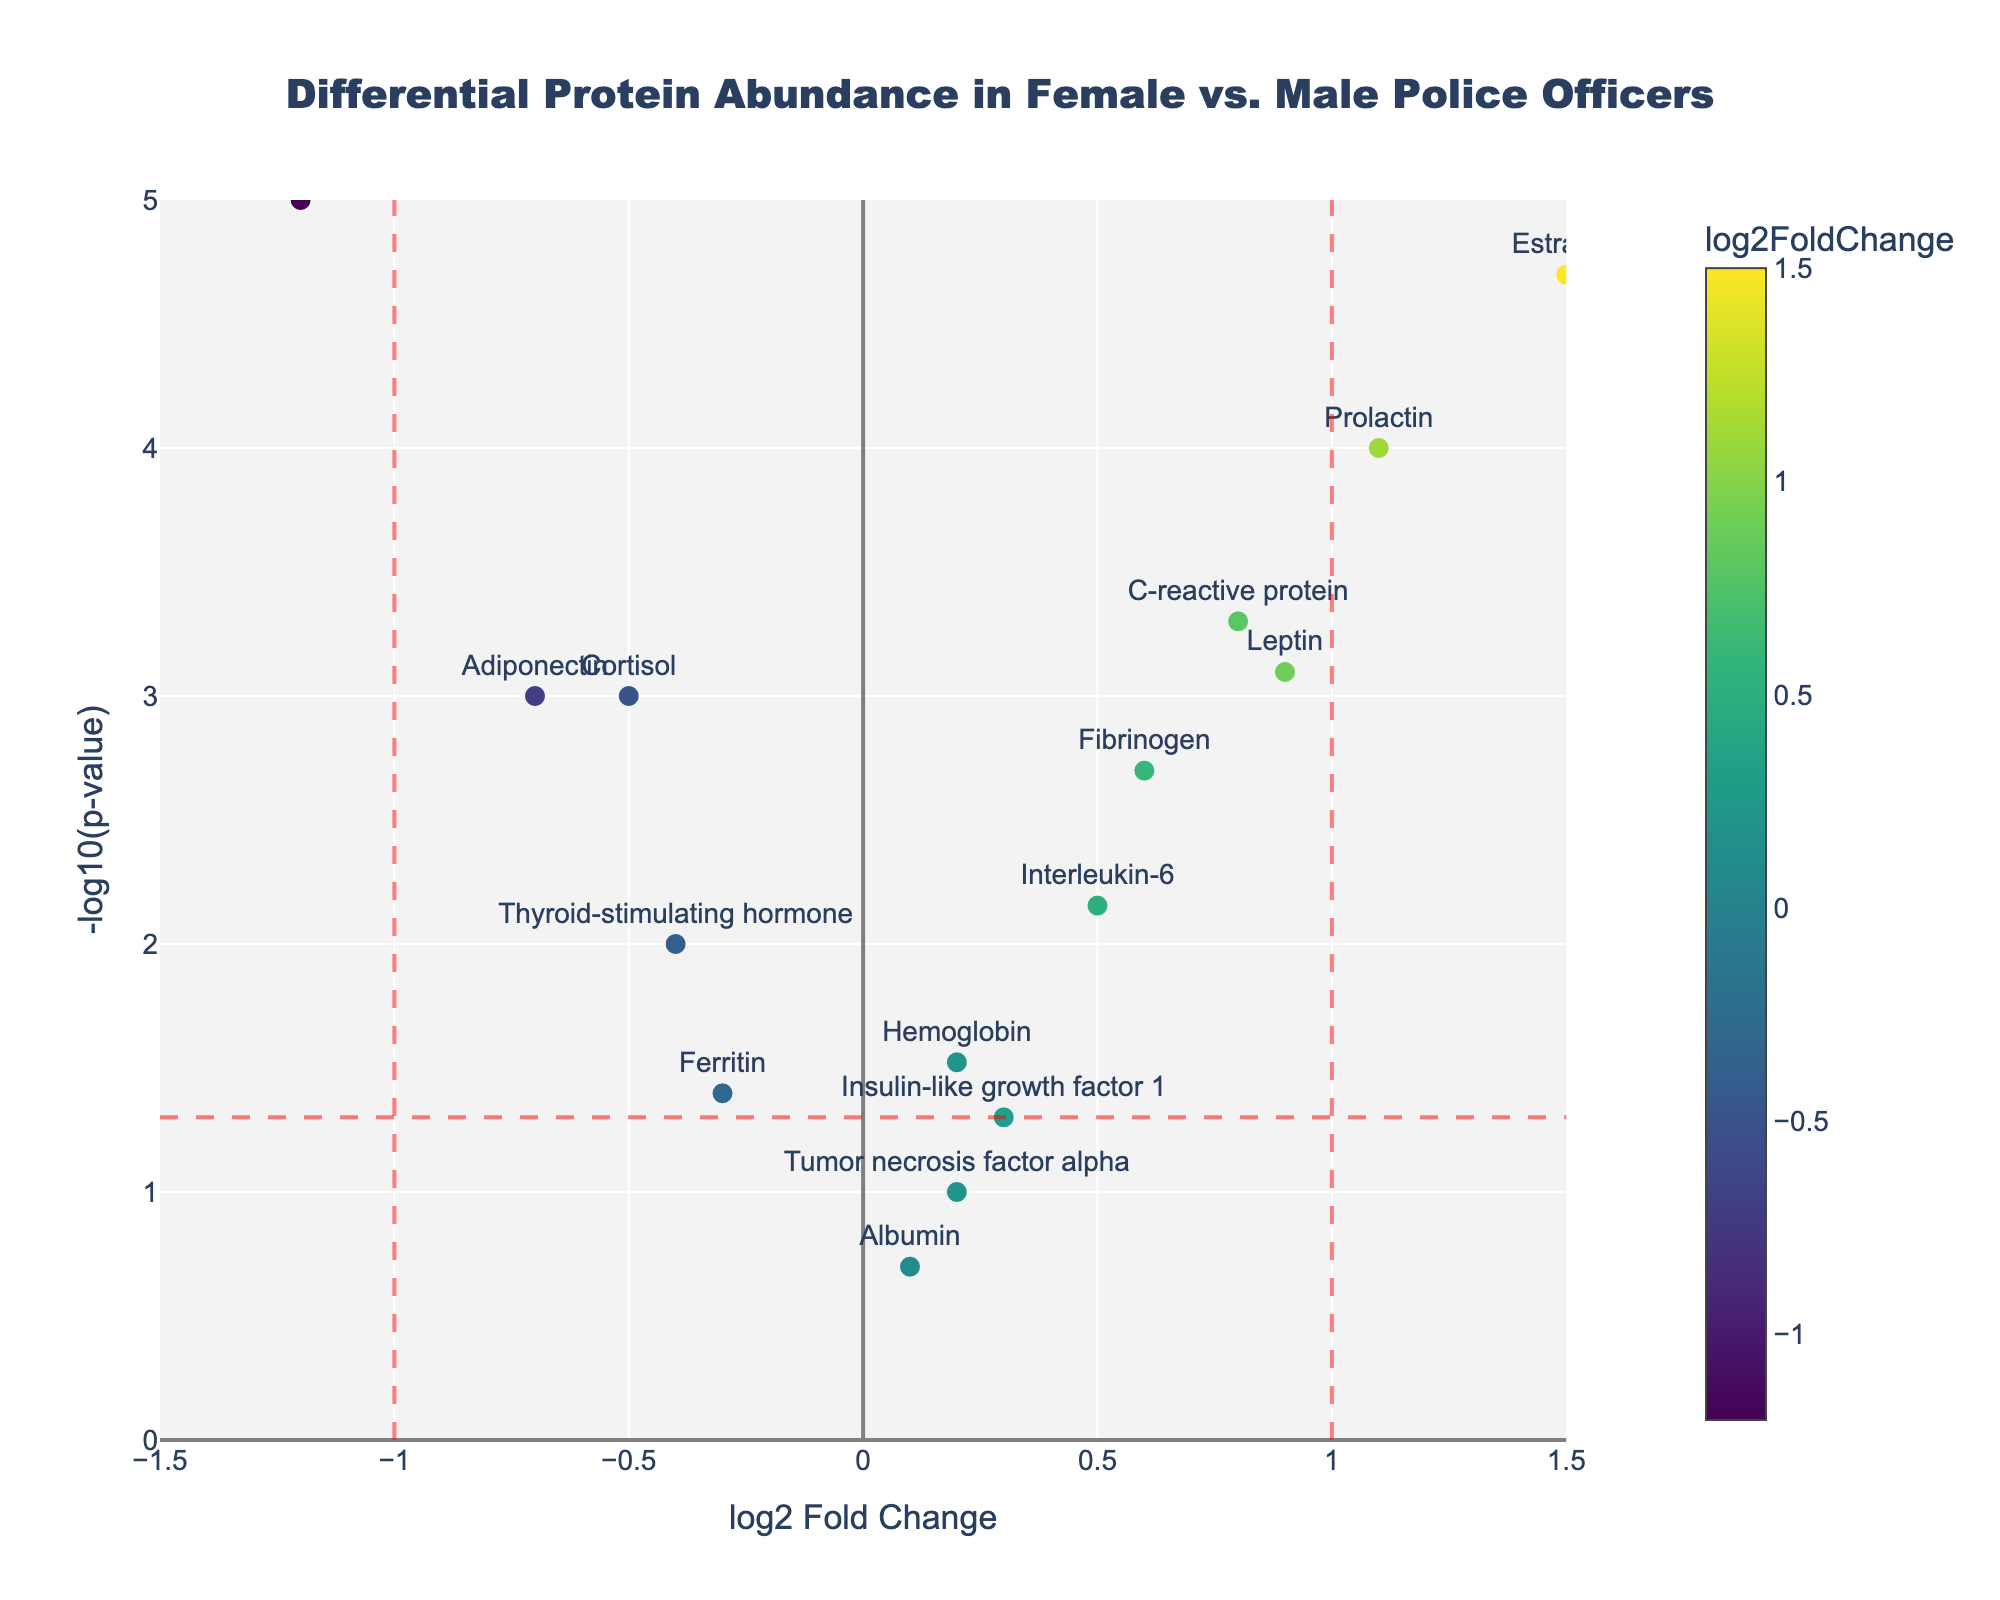What is the title of the plot? The title is located at the top center of the plot.
Answer: Differential Protein Abundance in Female vs. Male Police Officers What is the color scale used for the markers? The color scale used is indicated as 'Viridis,' which varies based on the log2FoldChange values.
Answer: Viridis How many proteins have a -log10(p-value) greater than 2? Count the number of points above the horizontal line at y=2, representing -log10(0.05).
Answer: 7 Which protein shows the highest log2FoldChange? The highest log2FoldChange is found at the rightmost point on the x-axis.
Answer: Estradiol Which proteins have log2FoldChange values less than -1? Identify the points left of the vertical line at x=-1 and note their labels.
Answer: Testosterone What is the -log10(p-value) for the protein C-reactive protein? Locate the point labeled 'C-reactive protein' and read off its y-axis value.
Answer: 3.30 How does the abundance of Cortisol in female officers compare to male officers? Cortisol is to the left of the x=0 line (negative log2FoldChange), indicating lower abundance in females.
Answer: Lower in females Which protein has the smallest p-value? The smallest p-value corresponds to the highest point on the y-axis.
Answer: Testosterone Compare the -log10(p-value) of Prolactin to Adiponectin. Which is higher? Compare the y-values of Prolactin and Adiponectin and see that Prolactin is higher.
Answer: Prolactin Which protein has a p-value closest to 0.05 but still significant? Find the point closest to the horizontal line at y=1.3 (representing p=0.05) but above it, thus significant.
Answer: Insulin-like growth factor 1 